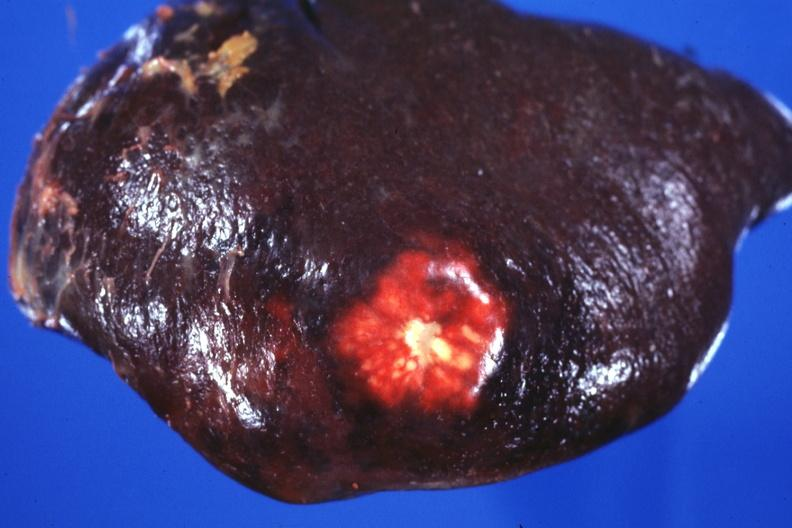what is present?
Answer the question using a single word or phrase. Metastatic colon carcinoma 